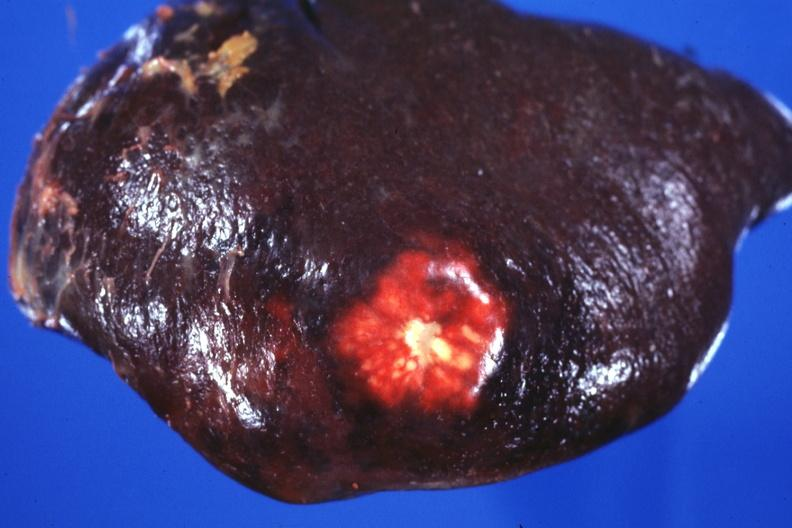what is present?
Answer the question using a single word or phrase. Metastatic colon carcinoma 